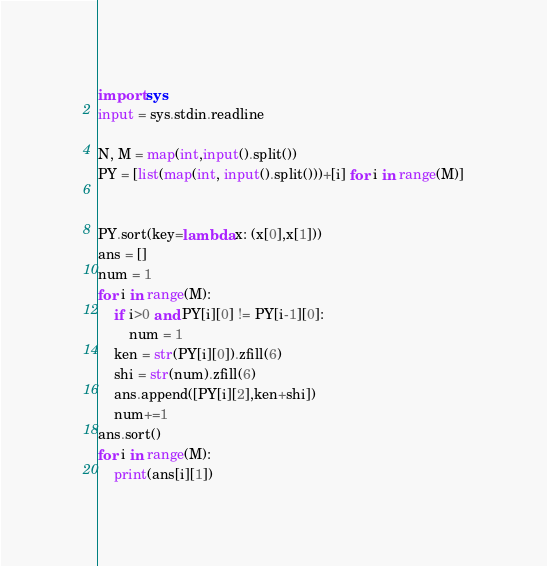Convert code to text. <code><loc_0><loc_0><loc_500><loc_500><_Python_>import sys
input = sys.stdin.readline

N, M = map(int,input().split())
PY = [list(map(int, input().split()))+[i] for i in range(M)]


PY.sort(key=lambda x: (x[0],x[1]))
ans = []
num = 1
for i in range(M):
    if i>0 and PY[i][0] != PY[i-1][0]:
        num = 1
    ken = str(PY[i][0]).zfill(6)
    shi = str(num).zfill(6)
    ans.append([PY[i][2],ken+shi])
    num+=1
ans.sort()
for i in range(M):
    print(ans[i][1])
</code> 